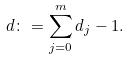<formula> <loc_0><loc_0><loc_500><loc_500>d \colon = \sum _ { j = 0 } ^ { m } d _ { j } - 1 .</formula> 